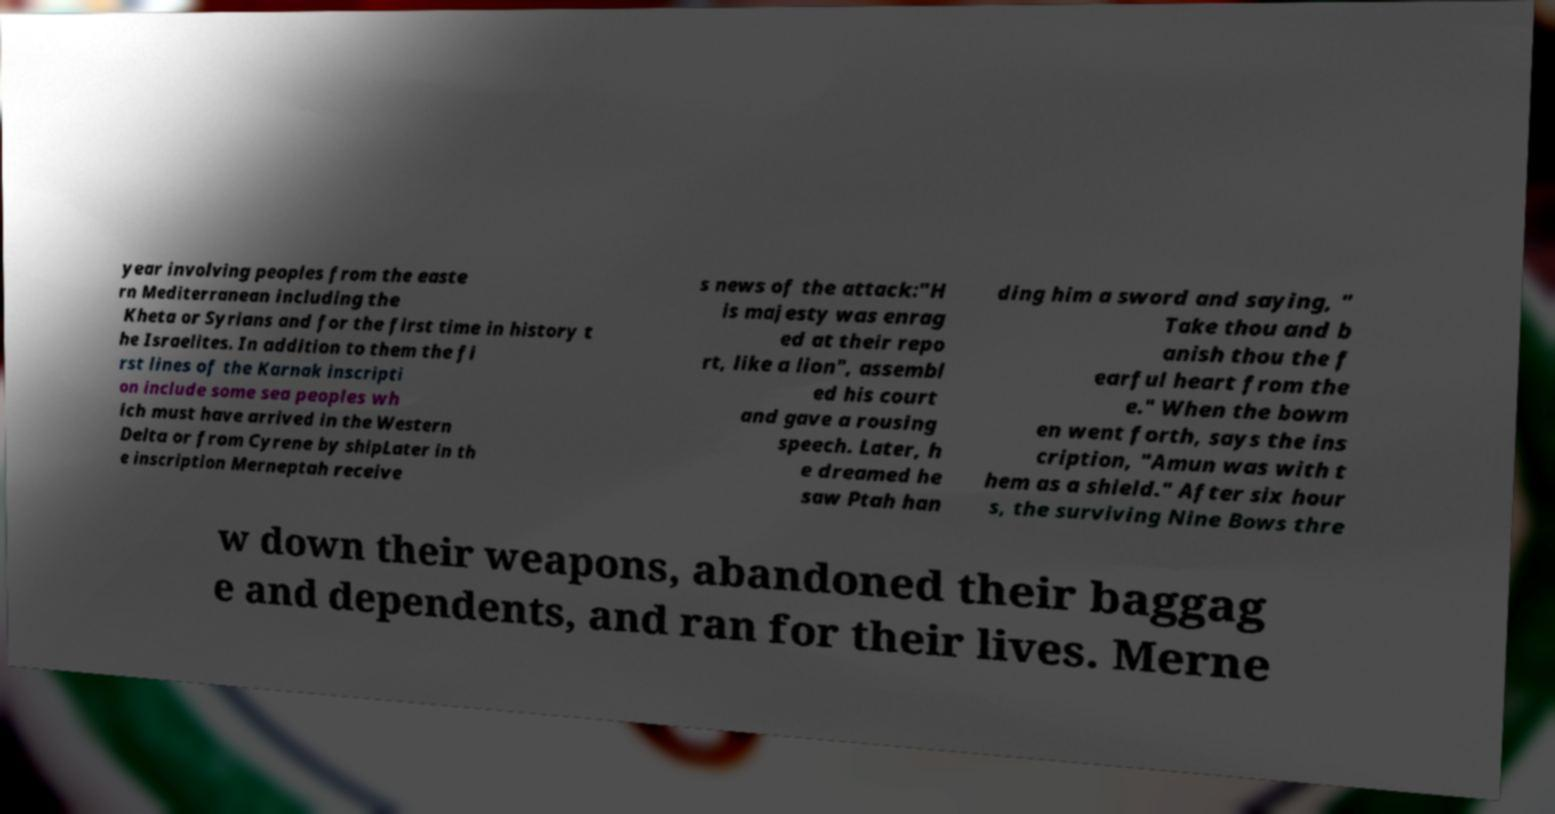I need the written content from this picture converted into text. Can you do that? year involving peoples from the easte rn Mediterranean including the Kheta or Syrians and for the first time in history t he Israelites. In addition to them the fi rst lines of the Karnak inscripti on include some sea peoples wh ich must have arrived in the Western Delta or from Cyrene by shipLater in th e inscription Merneptah receive s news of the attack:"H is majesty was enrag ed at their repo rt, like a lion", assembl ed his court and gave a rousing speech. Later, h e dreamed he saw Ptah han ding him a sword and saying, " Take thou and b anish thou the f earful heart from the e." When the bowm en went forth, says the ins cription, "Amun was with t hem as a shield." After six hour s, the surviving Nine Bows thre w down their weapons, abandoned their baggag e and dependents, and ran for their lives. Merne 